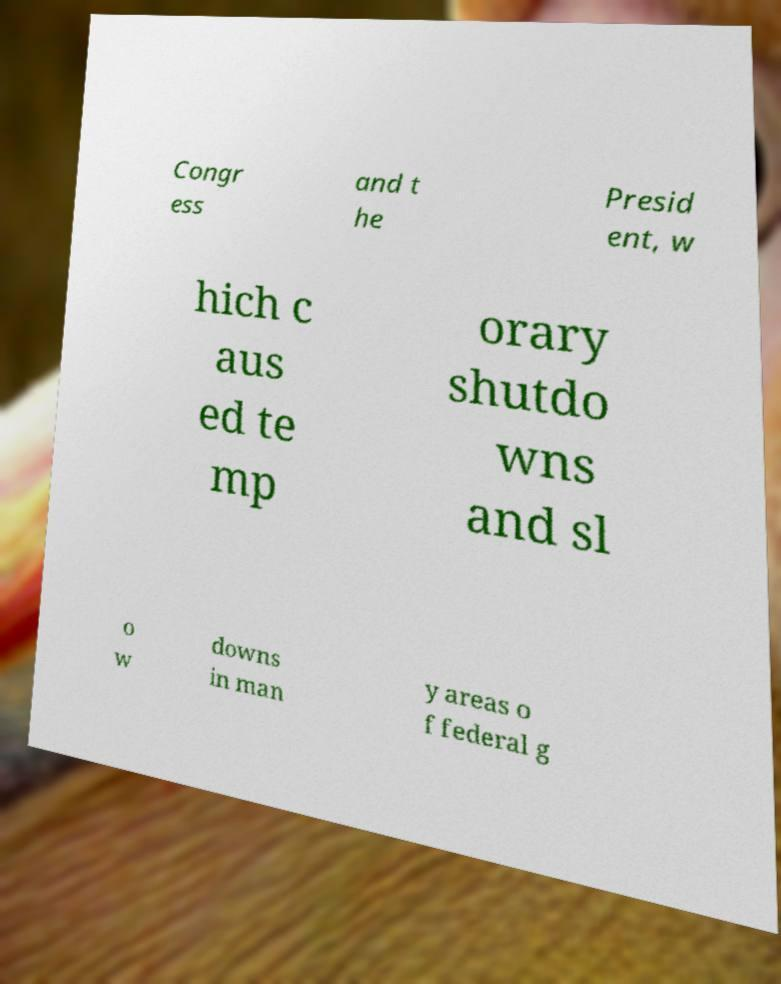I need the written content from this picture converted into text. Can you do that? Congr ess and t he Presid ent, w hich c aus ed te mp orary shutdo wns and sl o w downs in man y areas o f federal g 